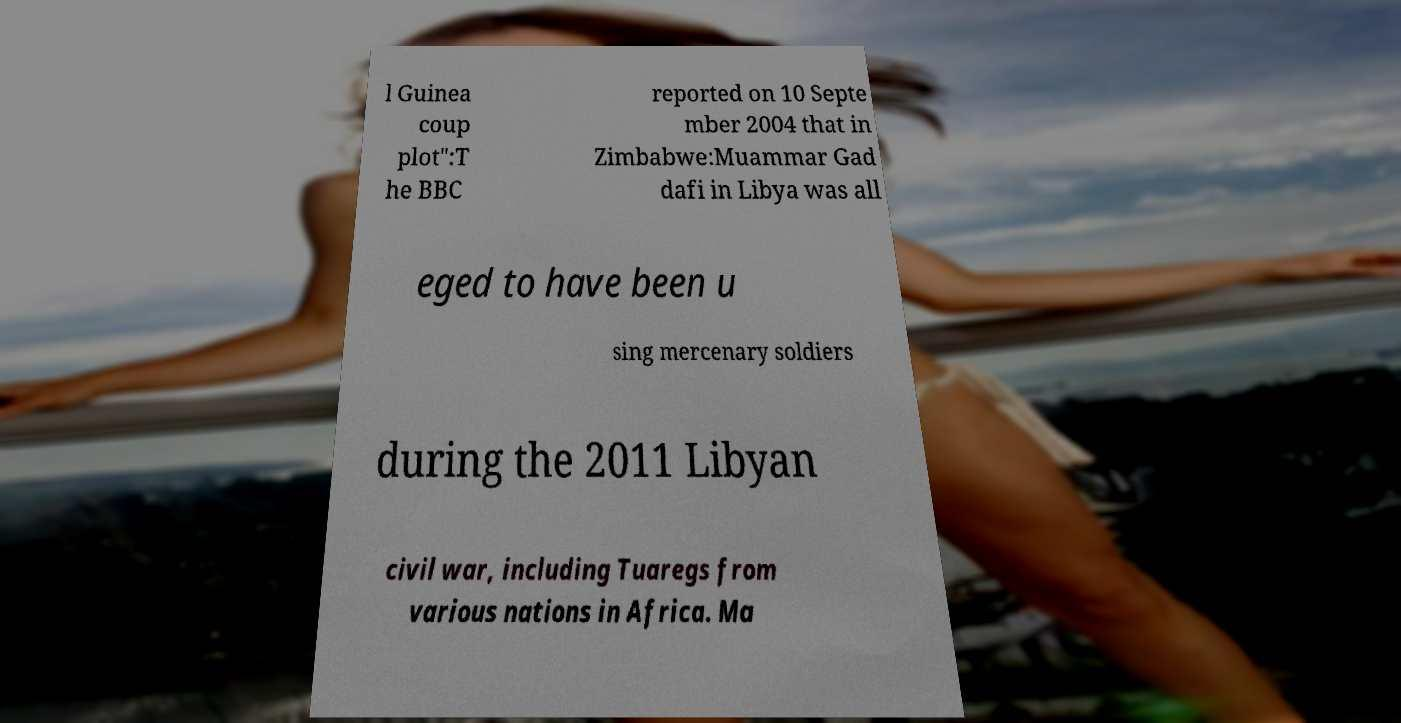For documentation purposes, I need the text within this image transcribed. Could you provide that? l Guinea coup plot":T he BBC reported on 10 Septe mber 2004 that in Zimbabwe:Muammar Gad dafi in Libya was all eged to have been u sing mercenary soldiers during the 2011 Libyan civil war, including Tuaregs from various nations in Africa. Ma 